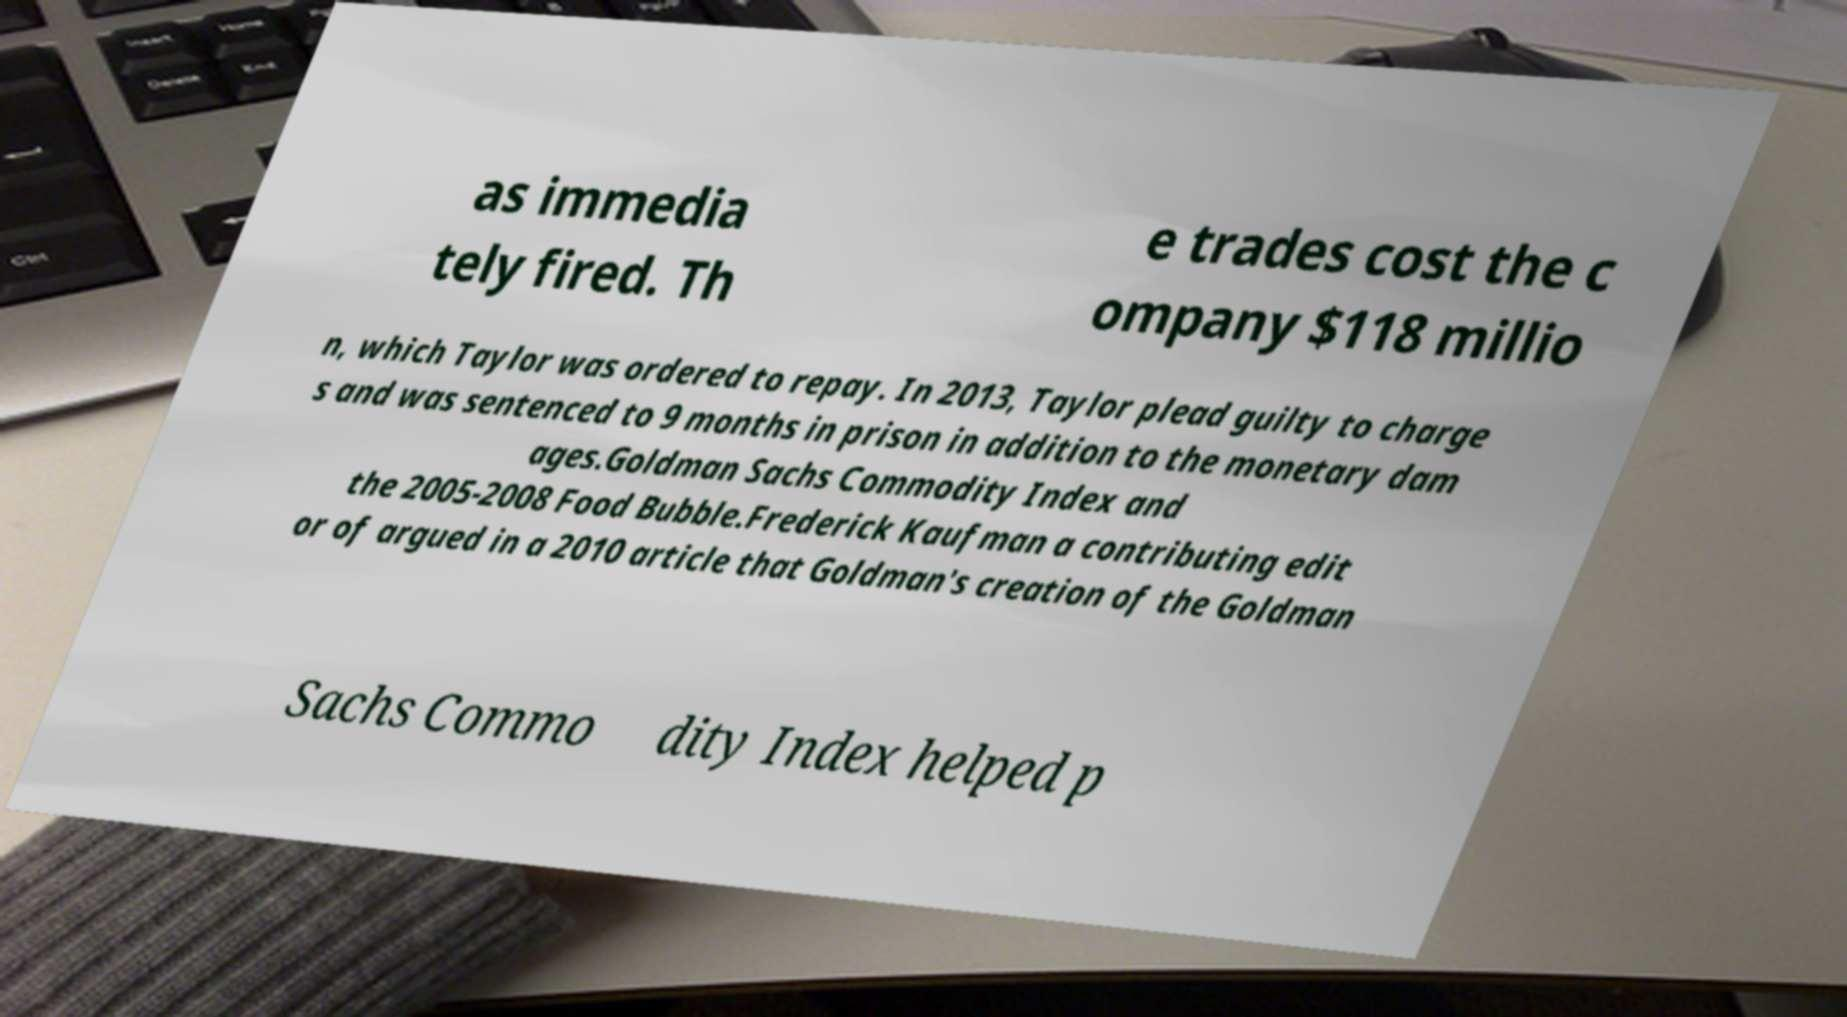Can you accurately transcribe the text from the provided image for me? as immedia tely fired. Th e trades cost the c ompany $118 millio n, which Taylor was ordered to repay. In 2013, Taylor plead guilty to charge s and was sentenced to 9 months in prison in addition to the monetary dam ages.Goldman Sachs Commodity Index and the 2005-2008 Food Bubble.Frederick Kaufman a contributing edit or of argued in a 2010 article that Goldman's creation of the Goldman Sachs Commo dity Index helped p 